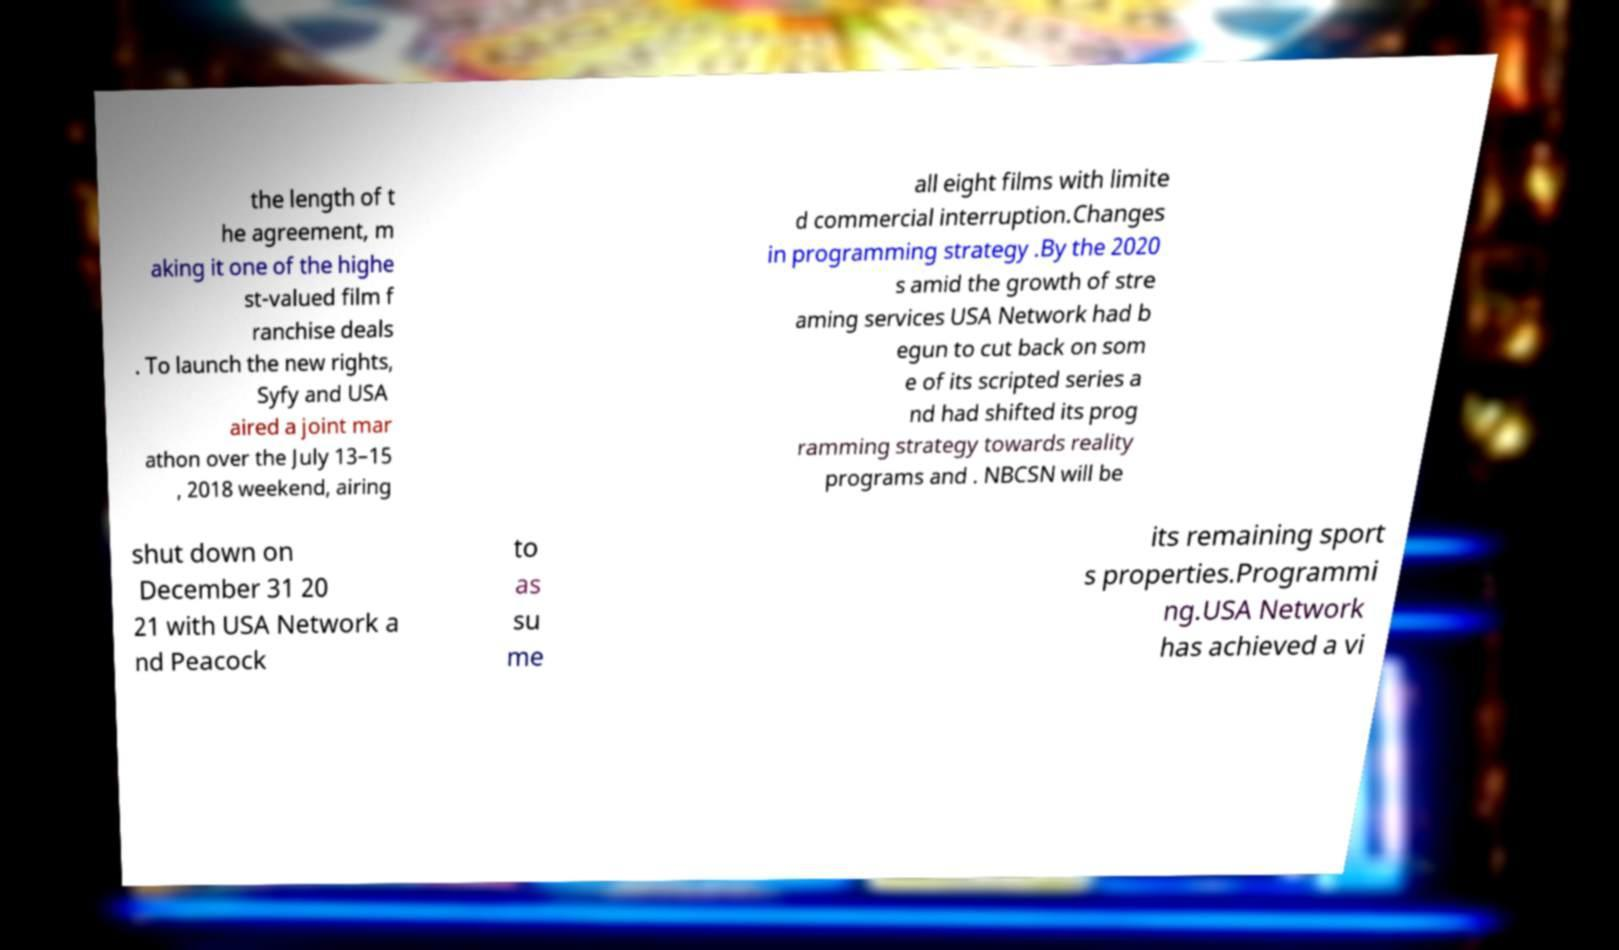Please identify and transcribe the text found in this image. the length of t he agreement, m aking it one of the highe st-valued film f ranchise deals . To launch the new rights, Syfy and USA aired a joint mar athon over the July 13–15 , 2018 weekend, airing all eight films with limite d commercial interruption.Changes in programming strategy .By the 2020 s amid the growth of stre aming services USA Network had b egun to cut back on som e of its scripted series a nd had shifted its prog ramming strategy towards reality programs and . NBCSN will be shut down on December 31 20 21 with USA Network a nd Peacock to as su me its remaining sport s properties.Programmi ng.USA Network has achieved a vi 